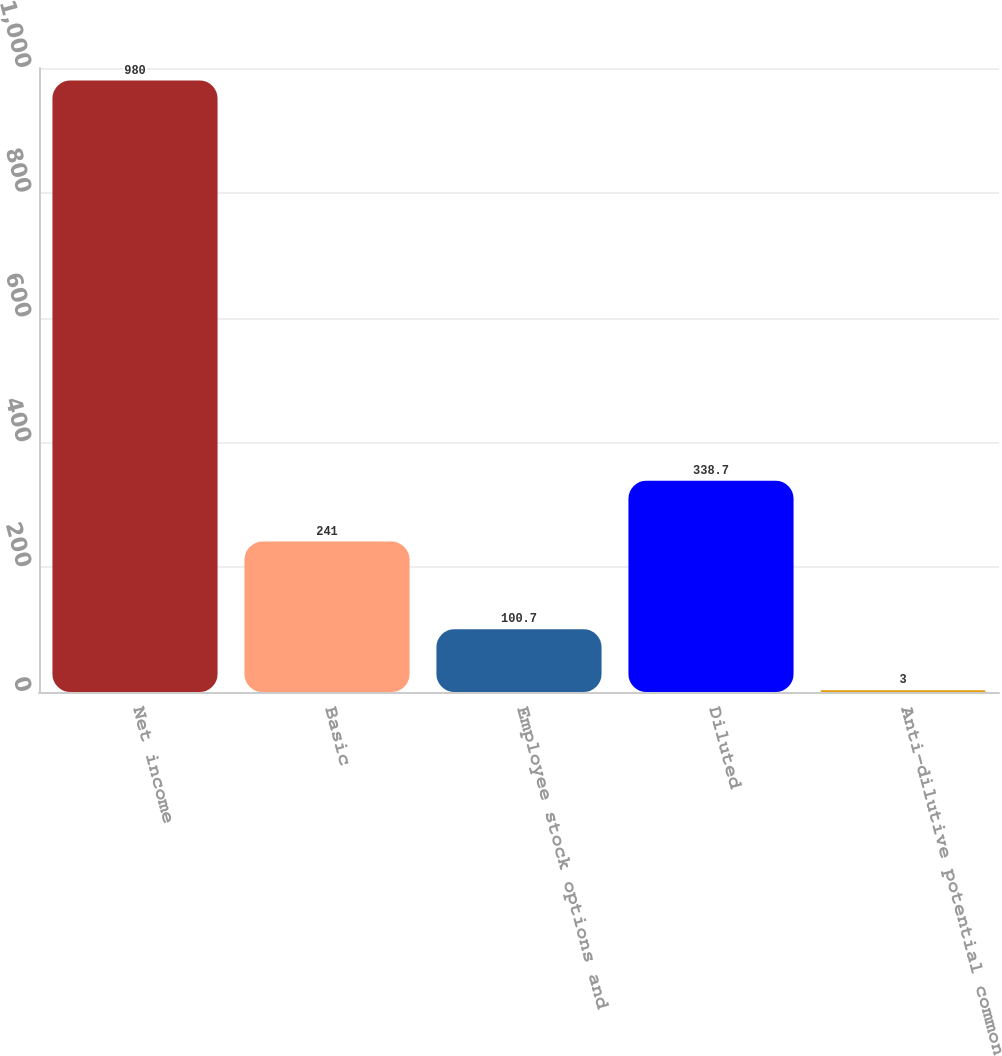Convert chart. <chart><loc_0><loc_0><loc_500><loc_500><bar_chart><fcel>Net income<fcel>Basic<fcel>Employee stock options and<fcel>Diluted<fcel>Anti-dilutive potential common<nl><fcel>980<fcel>241<fcel>100.7<fcel>338.7<fcel>3<nl></chart> 